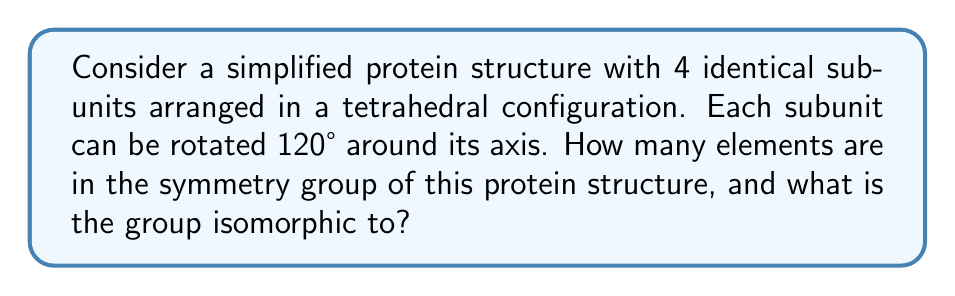Solve this math problem. To analyze the symmetry group of this protein structure, we need to consider both the tetrahedral symmetry and the rotational symmetry of each subunit.

1. Tetrahedral symmetry:
   The tetrahedral point group has 24 symmetry operations:
   - Identity: 1
   - Rotations around 4 C3 axes: 8 (2 for each axis)
   - Rotations around 3 C2 axes: 3
   - Reflections across 6 planes: 6
   - Improper rotations: 6

2. Subunit rotational symmetry:
   Each subunit can be rotated by 0°, 120°, or 240°. This gives 3 possible orientations for each subunit.

3. Total number of symmetry operations:
   We need to combine the tetrahedral symmetry with the subunit rotations. For each tetrahedral symmetry operation, we have $3^4 = 81$ possible combinations of subunit rotations (3 options for each of the 4 subunits).

   Total elements = 24 * 81 = 1,944

4. Group structure:
   This group is isomorphic to the direct product of the tetrahedral group and four copies of the cyclic group of order 3:

   $$ G \cong T_d \times C_3 \times C_3 \times C_3 \times C_3 $$

   Where $T_d$ is the tetrahedral group and $C_3$ is the cyclic group of order 3.

The order of this group is:
$$ |G| = |T_d| \cdot |C_3|^4 = 24 \cdot 3^4 = 1,944 $$

This matches our calculation in step 3.
Answer: The symmetry group of the protein structure has 1,944 elements and is isomorphic to $T_d \times C_3^4$. 